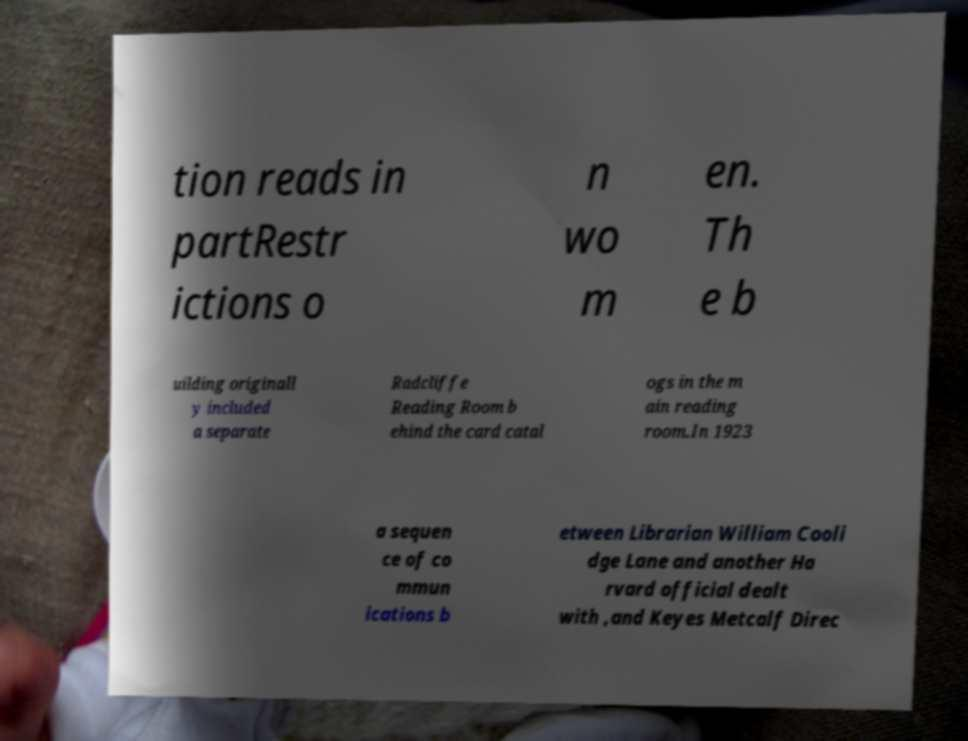What messages or text are displayed in this image? I need them in a readable, typed format. tion reads in partRestr ictions o n wo m en. Th e b uilding originall y included a separate Radcliffe Reading Room b ehind the card catal ogs in the m ain reading room.In 1923 a sequen ce of co mmun ications b etween Librarian William Cooli dge Lane and another Ha rvard official dealt with ,and Keyes Metcalf Direc 